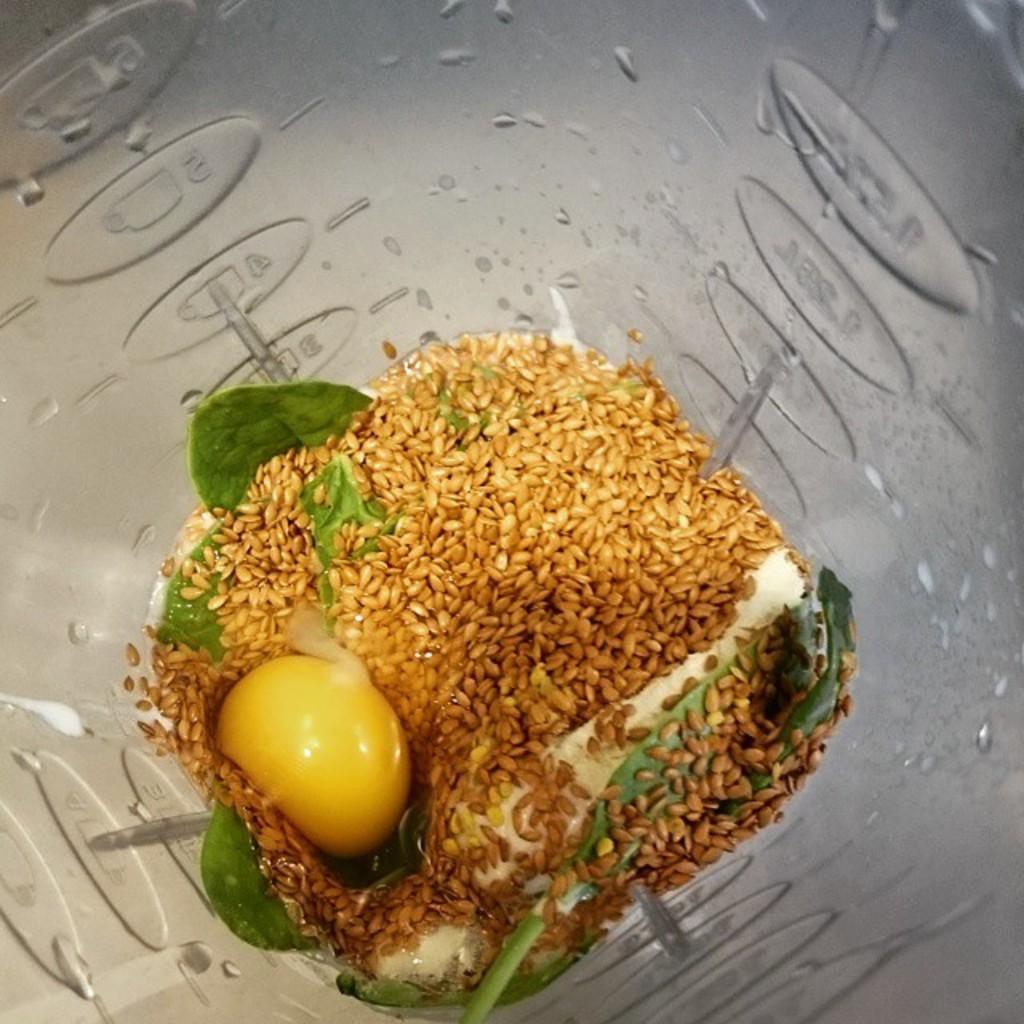In one or two sentences, can you explain what this image depicts? In the picture we can see a glass jar with some grains, mint leaf and some vegetable and to the jar we can see some water droplets. 